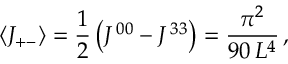Convert formula to latex. <formula><loc_0><loc_0><loc_500><loc_500>\langle J _ { + - } \rangle = \frac { 1 } { 2 } \left ( J ^ { \, 0 0 } - J ^ { \, 3 3 } \right ) = \frac { \pi ^ { 2 } } { 9 0 \, L ^ { 4 } } \, ,</formula> 